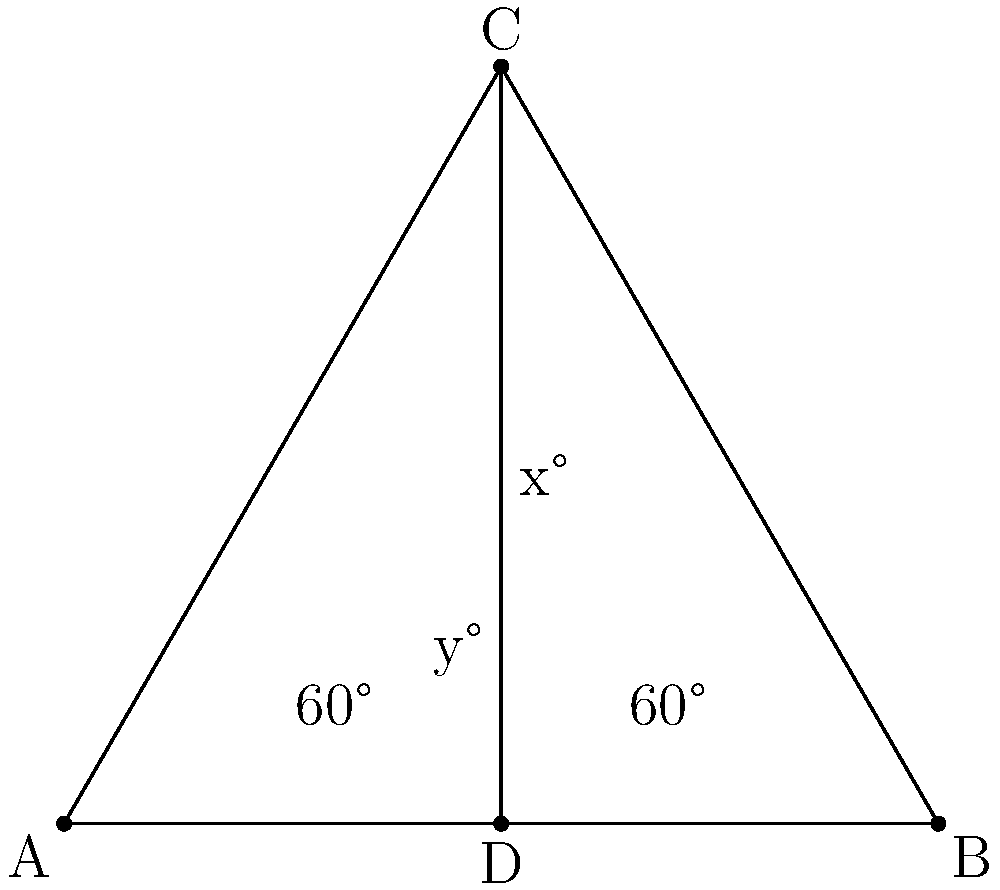During Eric Church's latest concert, two spotlights intersect on stage, creating the geometry shown above. If the base angles of the triangle are both 60°, what is the value of x + y? Let's approach this step-by-step:

1) In the diagram, we have an isosceles triangle ABC with base angles of 60°.

2) Since the sum of angles in a triangle is 180°, we can find the angle at C:
   $$180° - (60° + 60°) = 60°$$

3) Therefore, triangle ABC is equilateral, with all angles equal to 60°.

4) Line CD bisects angle ACB, creating two equal angles (x°) at C.
   $$x = 60° ÷ 2 = 30°$$

5) In triangle ACD, we now know two angles:
   - The angle at A is 60°
   - The angle at C is x° = 30°

6) Using the fact that angles in a triangle sum to 180°, we can find y:
   $$y = 180° - (60° + 30°) = 90°$$

7) The question asks for x + y:
   $$x + y = 30° + 90° = 120°$$
Answer: 120° 